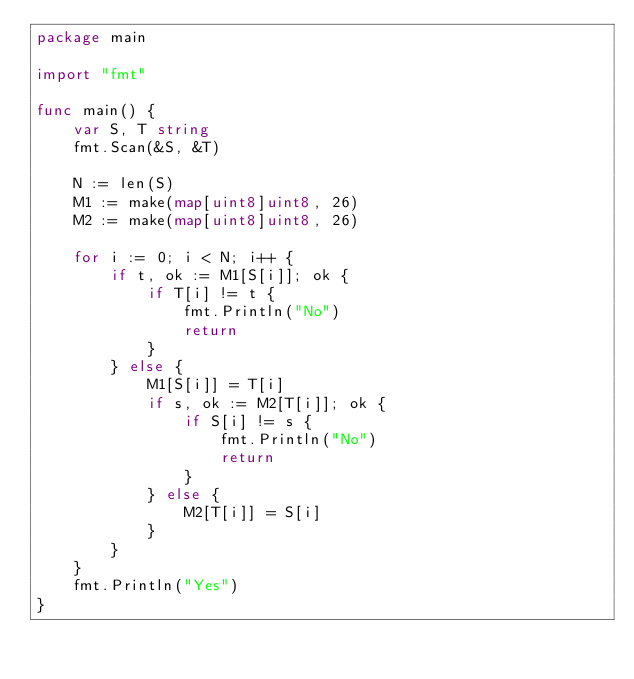<code> <loc_0><loc_0><loc_500><loc_500><_Go_>package main

import "fmt"

func main() {
	var S, T string
	fmt.Scan(&S, &T)

	N := len(S)
	M1 := make(map[uint8]uint8, 26)
	M2 := make(map[uint8]uint8, 26)

	for i := 0; i < N; i++ {
		if t, ok := M1[S[i]]; ok {
			if T[i] != t {
				fmt.Println("No")
				return
			}
		} else {
			M1[S[i]] = T[i]
			if s, ok := M2[T[i]]; ok {
				if S[i] != s {
					fmt.Println("No")
					return
				}
			} else {
				M2[T[i]] = S[i]
			}
		}
	}
	fmt.Println("Yes")
}
</code> 